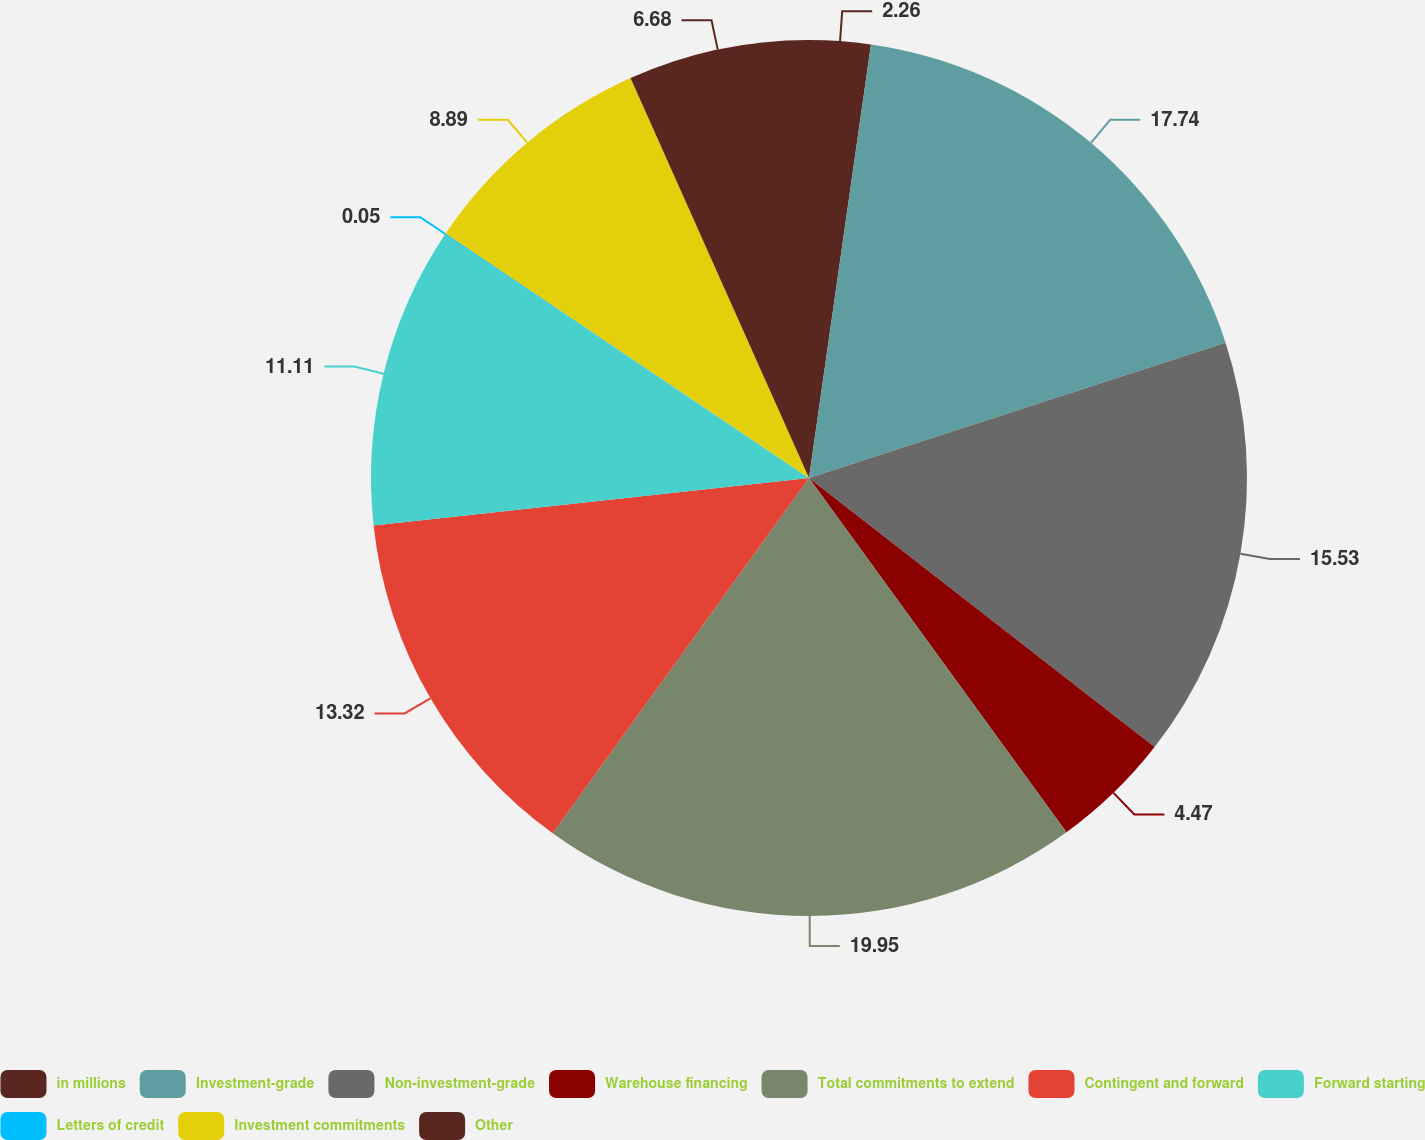Convert chart. <chart><loc_0><loc_0><loc_500><loc_500><pie_chart><fcel>in millions<fcel>Investment-grade<fcel>Non-investment-grade<fcel>Warehouse financing<fcel>Total commitments to extend<fcel>Contingent and forward<fcel>Forward starting<fcel>Letters of credit<fcel>Investment commitments<fcel>Other<nl><fcel>2.26%<fcel>17.74%<fcel>15.53%<fcel>4.47%<fcel>19.95%<fcel>13.32%<fcel>11.11%<fcel>0.05%<fcel>8.89%<fcel>6.68%<nl></chart> 